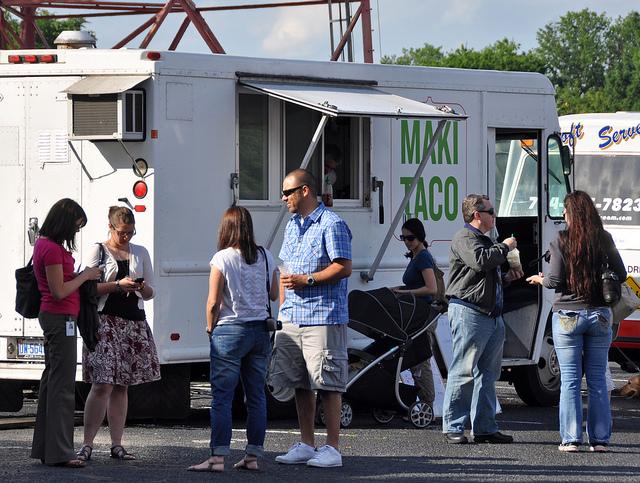Is there a baby stroller?
Answer briefly. Yes. Do you see a window AC?
Quick response, please. Yes. Are the people eating tacos?
Concise answer only. Yes. 